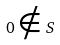Convert formula to latex. <formula><loc_0><loc_0><loc_500><loc_500>0 \notin S</formula> 